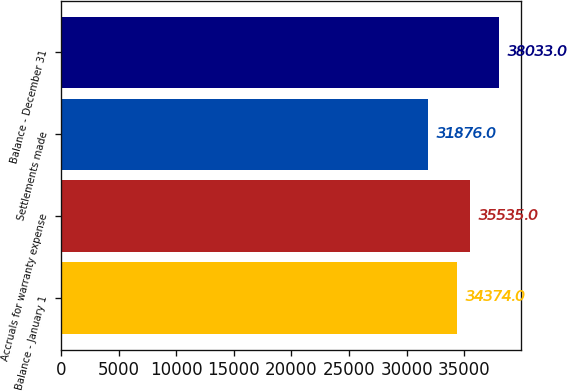<chart> <loc_0><loc_0><loc_500><loc_500><bar_chart><fcel>Balance - January 1<fcel>Accruals for warranty expense<fcel>Settlements made<fcel>Balance - December 31<nl><fcel>34374<fcel>35535<fcel>31876<fcel>38033<nl></chart> 